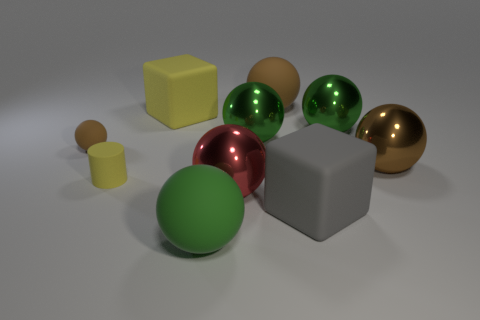What shape is the big brown thing that is the same material as the big red thing?
Make the answer very short. Sphere. Are there any big blocks that have the same color as the tiny rubber cylinder?
Provide a succinct answer. Yes. What number of shiny objects are big red objects or big brown objects?
Offer a very short reply. 2. There is a big cube to the right of the large red shiny ball; how many green things are on the left side of it?
Offer a very short reply. 2. How many large gray objects have the same material as the yellow block?
Your response must be concise. 1. How many big things are either purple rubber cubes or yellow matte cubes?
Give a very brief answer. 1. There is a large thing that is both to the right of the large brown rubber ball and in front of the large red metal sphere; what is its shape?
Offer a very short reply. Cube. Do the big yellow block and the tiny cylinder have the same material?
Give a very brief answer. Yes. What color is the cube that is the same size as the gray matte thing?
Provide a succinct answer. Yellow. What color is the thing that is both on the right side of the small brown matte sphere and to the left of the big yellow matte cube?
Make the answer very short. Yellow. 